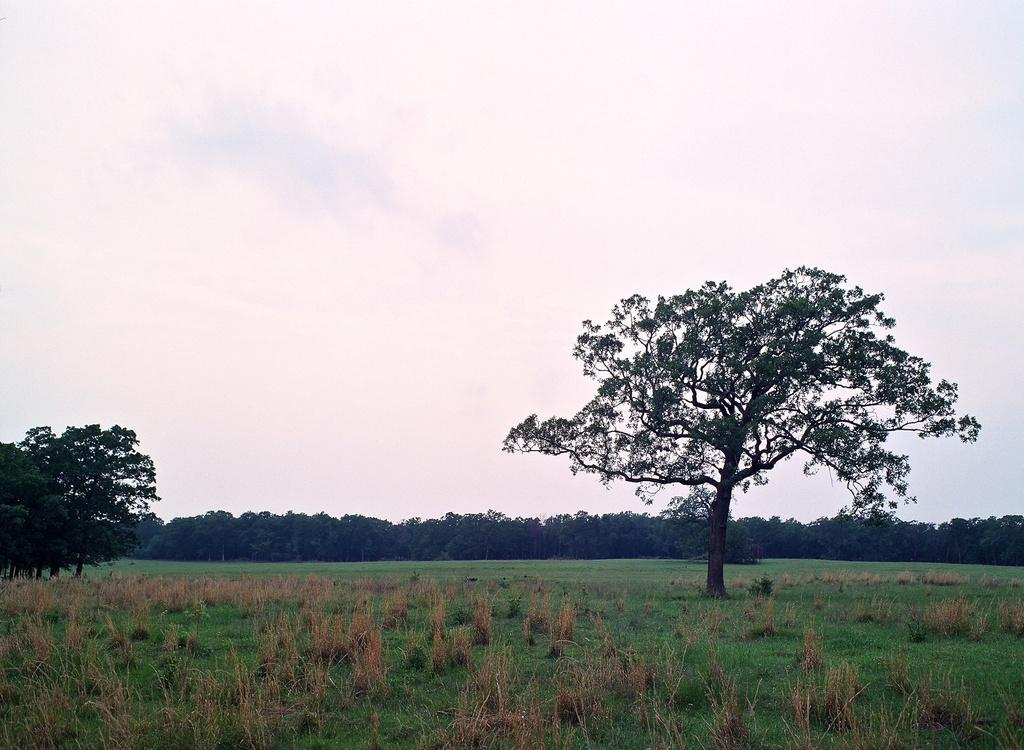What type of vegetation can be seen in the image? There are trees in the image. What is visible at the top of the image? The sky is visible at the top of the image. What can be seen in the sky? There are clouds in the sky. What type of ground cover is present at the bottom of the image? Grass is present at the bottom of the image. What other type of vegetation is present at the bottom of the image? There are plants at the bottom of the image. How many chairs are visible in the image? There are no chairs present in the image. What effect does the temper of the plants have on the image? There is no mention of the temper of the plants in the image, and therefore no effect can be determined. 